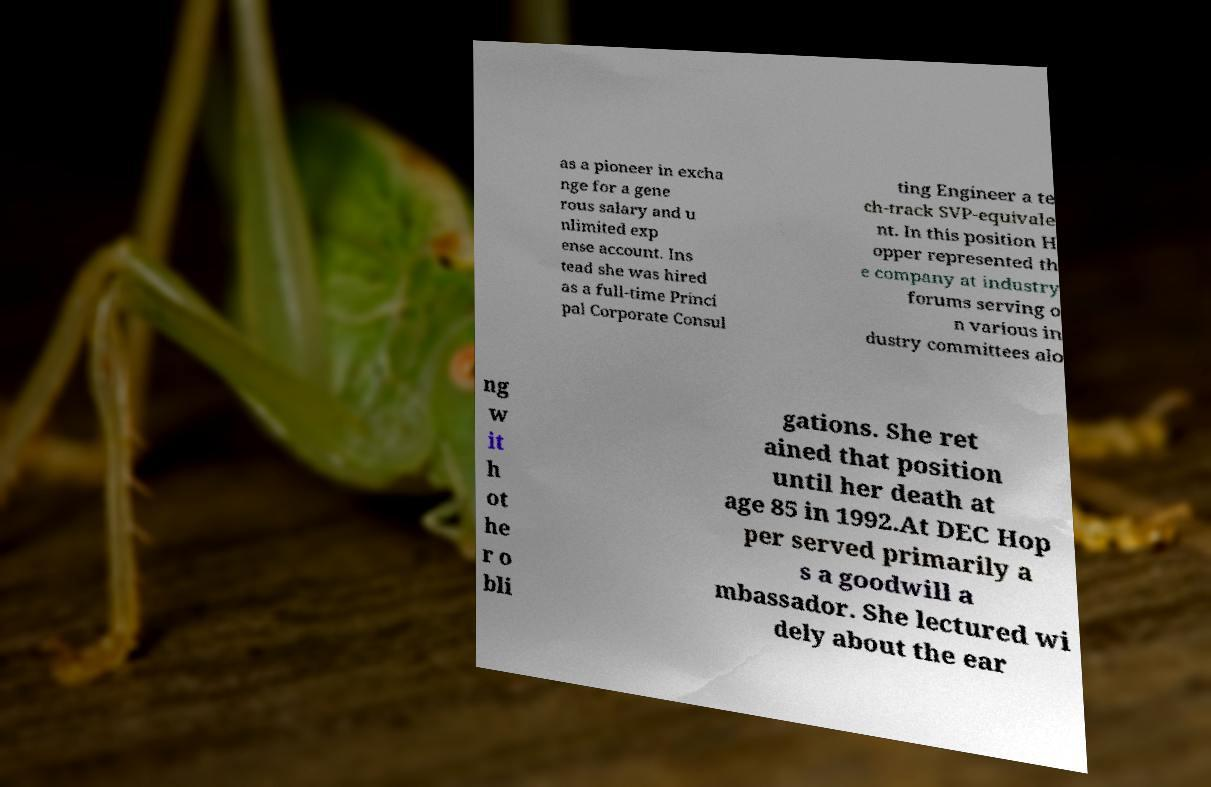Please read and relay the text visible in this image. What does it say? as a pioneer in excha nge for a gene rous salary and u nlimited exp ense account. Ins tead she was hired as a full-time Princi pal Corporate Consul ting Engineer a te ch-track SVP-equivale nt. In this position H opper represented th e company at industry forums serving o n various in dustry committees alo ng w it h ot he r o bli gations. She ret ained that position until her death at age 85 in 1992.At DEC Hop per served primarily a s a goodwill a mbassador. She lectured wi dely about the ear 